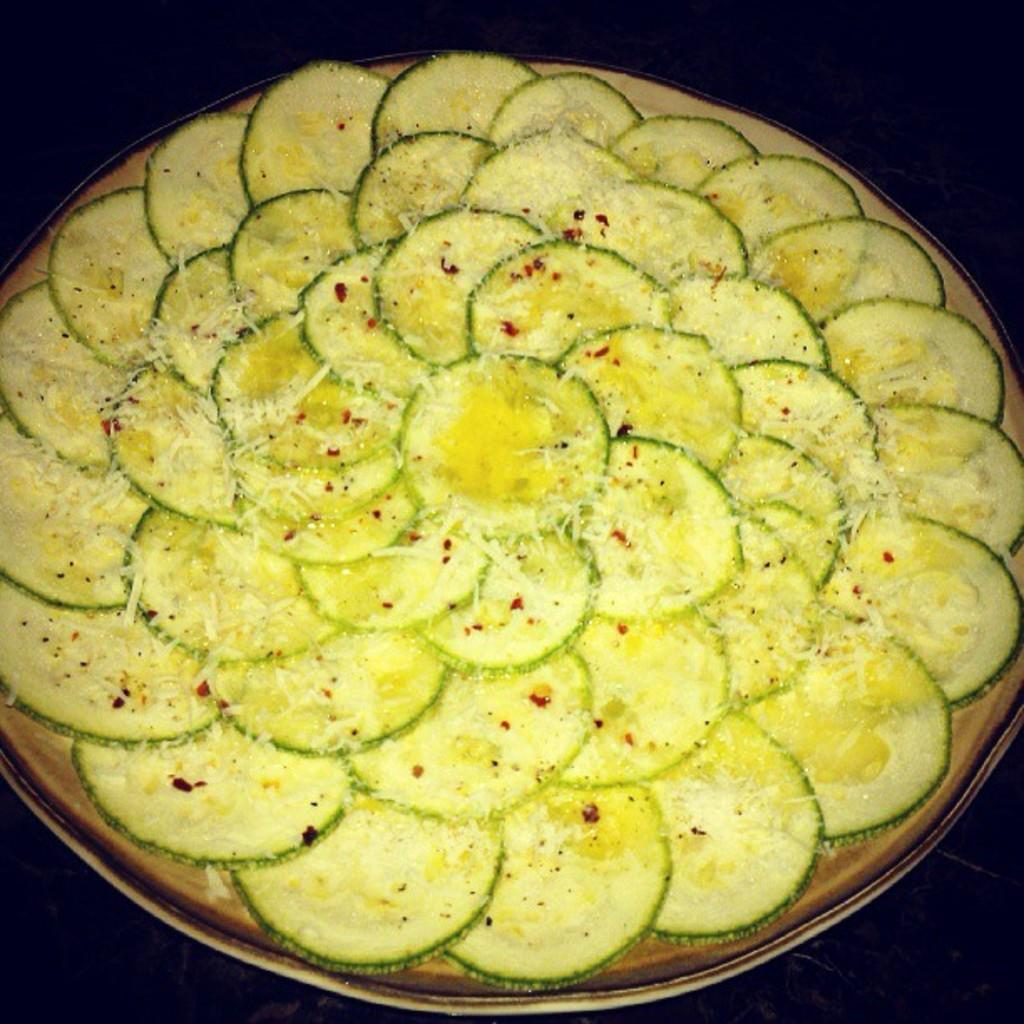What is on the serving plate in the image? The serving plate contains salad. Can you describe the main dish on the plate? The main dish on the plate is a salad. What type of ear is visible in the image? There is no ear present in the image. What is the ground like in the image? The image does not show any ground; it only shows a serving plate with salad. 